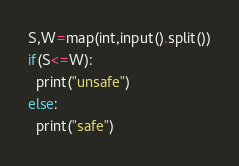Convert code to text. <code><loc_0><loc_0><loc_500><loc_500><_Python_>S,W=map(int,input().split())
if(S<=W):
  print("unsafe")
else:
  print("safe")</code> 